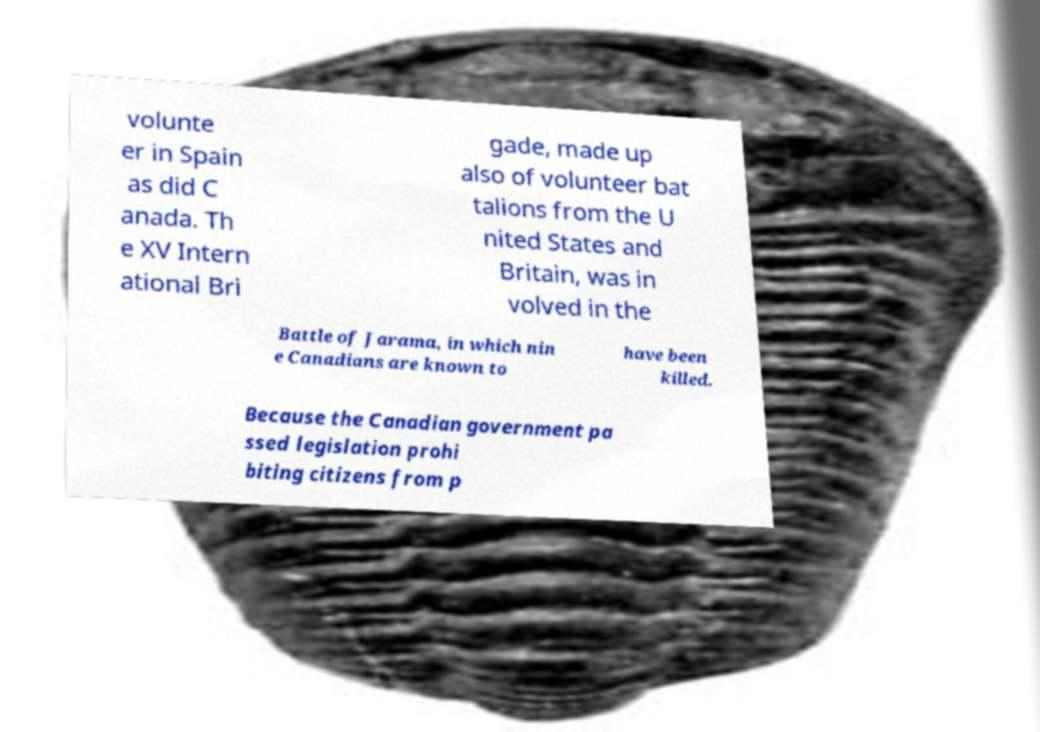Could you extract and type out the text from this image? volunte er in Spain as did C anada. Th e XV Intern ational Bri gade, made up also of volunteer bat talions from the U nited States and Britain, was in volved in the Battle of Jarama, in which nin e Canadians are known to have been killed. Because the Canadian government pa ssed legislation prohi biting citizens from p 